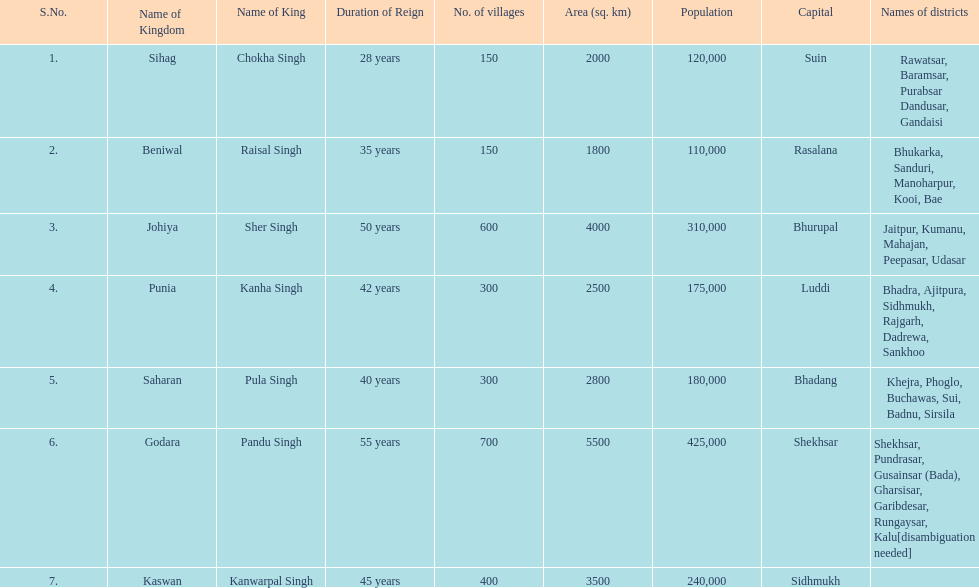Which kingdom has the most villages? Godara. 